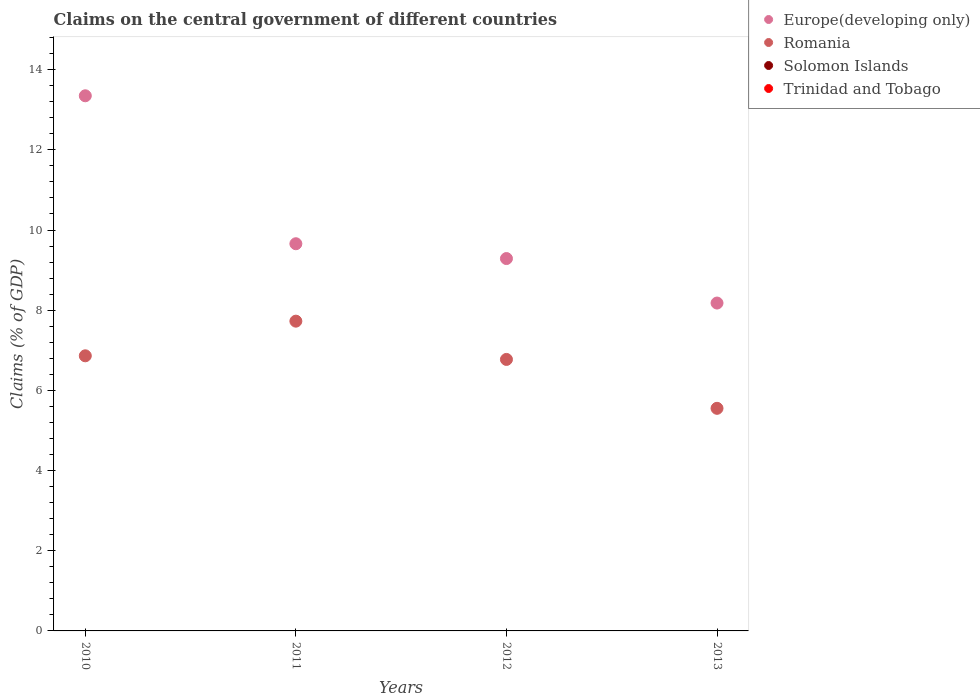How many different coloured dotlines are there?
Keep it short and to the point. 2. What is the percentage of GDP claimed on the central government in Romania in 2011?
Your response must be concise. 7.73. Across all years, what is the maximum percentage of GDP claimed on the central government in Europe(developing only)?
Offer a terse response. 13.35. What is the difference between the percentage of GDP claimed on the central government in Romania in 2010 and that in 2011?
Provide a succinct answer. -0.86. What is the difference between the percentage of GDP claimed on the central government in Europe(developing only) in 2013 and the percentage of GDP claimed on the central government in Romania in 2010?
Your response must be concise. 1.32. What is the average percentage of GDP claimed on the central government in Europe(developing only) per year?
Your response must be concise. 10.12. In the year 2012, what is the difference between the percentage of GDP claimed on the central government in Romania and percentage of GDP claimed on the central government in Europe(developing only)?
Keep it short and to the point. -2.52. What is the ratio of the percentage of GDP claimed on the central government in Romania in 2010 to that in 2013?
Offer a very short reply. 1.24. Is the percentage of GDP claimed on the central government in Europe(developing only) in 2010 less than that in 2012?
Offer a very short reply. No. Is the difference between the percentage of GDP claimed on the central government in Romania in 2011 and 2012 greater than the difference between the percentage of GDP claimed on the central government in Europe(developing only) in 2011 and 2012?
Keep it short and to the point. Yes. What is the difference between the highest and the second highest percentage of GDP claimed on the central government in Romania?
Provide a succinct answer. 0.86. What is the difference between the highest and the lowest percentage of GDP claimed on the central government in Europe(developing only)?
Ensure brevity in your answer.  5.17. In how many years, is the percentage of GDP claimed on the central government in Trinidad and Tobago greater than the average percentage of GDP claimed on the central government in Trinidad and Tobago taken over all years?
Offer a very short reply. 0. Is the sum of the percentage of GDP claimed on the central government in Romania in 2011 and 2012 greater than the maximum percentage of GDP claimed on the central government in Europe(developing only) across all years?
Offer a very short reply. Yes. Is it the case that in every year, the sum of the percentage of GDP claimed on the central government in Europe(developing only) and percentage of GDP claimed on the central government in Solomon Islands  is greater than the percentage of GDP claimed on the central government in Trinidad and Tobago?
Make the answer very short. Yes. Does the percentage of GDP claimed on the central government in Europe(developing only) monotonically increase over the years?
Provide a short and direct response. No. How many years are there in the graph?
Keep it short and to the point. 4. Does the graph contain any zero values?
Give a very brief answer. Yes. Does the graph contain grids?
Your answer should be very brief. No. How many legend labels are there?
Ensure brevity in your answer.  4. How are the legend labels stacked?
Your response must be concise. Vertical. What is the title of the graph?
Ensure brevity in your answer.  Claims on the central government of different countries. Does "Gambia, The" appear as one of the legend labels in the graph?
Your answer should be compact. No. What is the label or title of the X-axis?
Provide a short and direct response. Years. What is the label or title of the Y-axis?
Provide a succinct answer. Claims (% of GDP). What is the Claims (% of GDP) of Europe(developing only) in 2010?
Keep it short and to the point. 13.35. What is the Claims (% of GDP) in Romania in 2010?
Your response must be concise. 6.86. What is the Claims (% of GDP) in Solomon Islands in 2010?
Provide a succinct answer. 0. What is the Claims (% of GDP) of Trinidad and Tobago in 2010?
Offer a terse response. 0. What is the Claims (% of GDP) of Europe(developing only) in 2011?
Offer a terse response. 9.66. What is the Claims (% of GDP) of Romania in 2011?
Ensure brevity in your answer.  7.73. What is the Claims (% of GDP) of Solomon Islands in 2011?
Your answer should be very brief. 0. What is the Claims (% of GDP) of Trinidad and Tobago in 2011?
Make the answer very short. 0. What is the Claims (% of GDP) in Europe(developing only) in 2012?
Your answer should be very brief. 9.29. What is the Claims (% of GDP) in Romania in 2012?
Give a very brief answer. 6.77. What is the Claims (% of GDP) in Europe(developing only) in 2013?
Ensure brevity in your answer.  8.18. What is the Claims (% of GDP) in Romania in 2013?
Offer a terse response. 5.55. What is the Claims (% of GDP) in Solomon Islands in 2013?
Your response must be concise. 0. Across all years, what is the maximum Claims (% of GDP) of Europe(developing only)?
Provide a short and direct response. 13.35. Across all years, what is the maximum Claims (% of GDP) of Romania?
Give a very brief answer. 7.73. Across all years, what is the minimum Claims (% of GDP) of Europe(developing only)?
Provide a short and direct response. 8.18. Across all years, what is the minimum Claims (% of GDP) in Romania?
Offer a very short reply. 5.55. What is the total Claims (% of GDP) of Europe(developing only) in the graph?
Give a very brief answer. 40.47. What is the total Claims (% of GDP) in Romania in the graph?
Keep it short and to the point. 26.91. What is the difference between the Claims (% of GDP) of Europe(developing only) in 2010 and that in 2011?
Your answer should be very brief. 3.69. What is the difference between the Claims (% of GDP) of Romania in 2010 and that in 2011?
Ensure brevity in your answer.  -0.86. What is the difference between the Claims (% of GDP) in Europe(developing only) in 2010 and that in 2012?
Ensure brevity in your answer.  4.06. What is the difference between the Claims (% of GDP) in Romania in 2010 and that in 2012?
Make the answer very short. 0.09. What is the difference between the Claims (% of GDP) of Europe(developing only) in 2010 and that in 2013?
Give a very brief answer. 5.17. What is the difference between the Claims (% of GDP) in Romania in 2010 and that in 2013?
Provide a succinct answer. 1.31. What is the difference between the Claims (% of GDP) of Europe(developing only) in 2011 and that in 2012?
Offer a very short reply. 0.37. What is the difference between the Claims (% of GDP) in Romania in 2011 and that in 2012?
Provide a succinct answer. 0.95. What is the difference between the Claims (% of GDP) in Europe(developing only) in 2011 and that in 2013?
Ensure brevity in your answer.  1.48. What is the difference between the Claims (% of GDP) of Romania in 2011 and that in 2013?
Offer a terse response. 2.17. What is the difference between the Claims (% of GDP) in Europe(developing only) in 2012 and that in 2013?
Your response must be concise. 1.11. What is the difference between the Claims (% of GDP) in Romania in 2012 and that in 2013?
Offer a terse response. 1.22. What is the difference between the Claims (% of GDP) in Europe(developing only) in 2010 and the Claims (% of GDP) in Romania in 2011?
Ensure brevity in your answer.  5.62. What is the difference between the Claims (% of GDP) of Europe(developing only) in 2010 and the Claims (% of GDP) of Romania in 2012?
Make the answer very short. 6.58. What is the difference between the Claims (% of GDP) of Europe(developing only) in 2010 and the Claims (% of GDP) of Romania in 2013?
Your response must be concise. 7.8. What is the difference between the Claims (% of GDP) in Europe(developing only) in 2011 and the Claims (% of GDP) in Romania in 2012?
Your response must be concise. 2.89. What is the difference between the Claims (% of GDP) in Europe(developing only) in 2011 and the Claims (% of GDP) in Romania in 2013?
Your answer should be compact. 4.11. What is the difference between the Claims (% of GDP) of Europe(developing only) in 2012 and the Claims (% of GDP) of Romania in 2013?
Keep it short and to the point. 3.74. What is the average Claims (% of GDP) in Europe(developing only) per year?
Offer a very short reply. 10.12. What is the average Claims (% of GDP) in Romania per year?
Give a very brief answer. 6.73. What is the average Claims (% of GDP) of Solomon Islands per year?
Your answer should be very brief. 0. What is the average Claims (% of GDP) of Trinidad and Tobago per year?
Offer a very short reply. 0. In the year 2010, what is the difference between the Claims (% of GDP) in Europe(developing only) and Claims (% of GDP) in Romania?
Your answer should be very brief. 6.49. In the year 2011, what is the difference between the Claims (% of GDP) in Europe(developing only) and Claims (% of GDP) in Romania?
Ensure brevity in your answer.  1.93. In the year 2012, what is the difference between the Claims (% of GDP) in Europe(developing only) and Claims (% of GDP) in Romania?
Ensure brevity in your answer.  2.52. In the year 2013, what is the difference between the Claims (% of GDP) of Europe(developing only) and Claims (% of GDP) of Romania?
Offer a terse response. 2.63. What is the ratio of the Claims (% of GDP) of Europe(developing only) in 2010 to that in 2011?
Offer a terse response. 1.38. What is the ratio of the Claims (% of GDP) of Romania in 2010 to that in 2011?
Offer a terse response. 0.89. What is the ratio of the Claims (% of GDP) in Europe(developing only) in 2010 to that in 2012?
Give a very brief answer. 1.44. What is the ratio of the Claims (% of GDP) of Romania in 2010 to that in 2012?
Your answer should be compact. 1.01. What is the ratio of the Claims (% of GDP) in Europe(developing only) in 2010 to that in 2013?
Offer a very short reply. 1.63. What is the ratio of the Claims (% of GDP) of Romania in 2010 to that in 2013?
Make the answer very short. 1.24. What is the ratio of the Claims (% of GDP) of Europe(developing only) in 2011 to that in 2012?
Keep it short and to the point. 1.04. What is the ratio of the Claims (% of GDP) of Romania in 2011 to that in 2012?
Make the answer very short. 1.14. What is the ratio of the Claims (% of GDP) of Europe(developing only) in 2011 to that in 2013?
Provide a short and direct response. 1.18. What is the ratio of the Claims (% of GDP) in Romania in 2011 to that in 2013?
Provide a short and direct response. 1.39. What is the ratio of the Claims (% of GDP) in Europe(developing only) in 2012 to that in 2013?
Provide a succinct answer. 1.14. What is the ratio of the Claims (% of GDP) in Romania in 2012 to that in 2013?
Your response must be concise. 1.22. What is the difference between the highest and the second highest Claims (% of GDP) of Europe(developing only)?
Your response must be concise. 3.69. What is the difference between the highest and the second highest Claims (% of GDP) of Romania?
Keep it short and to the point. 0.86. What is the difference between the highest and the lowest Claims (% of GDP) in Europe(developing only)?
Give a very brief answer. 5.17. What is the difference between the highest and the lowest Claims (% of GDP) of Romania?
Your answer should be compact. 2.17. 